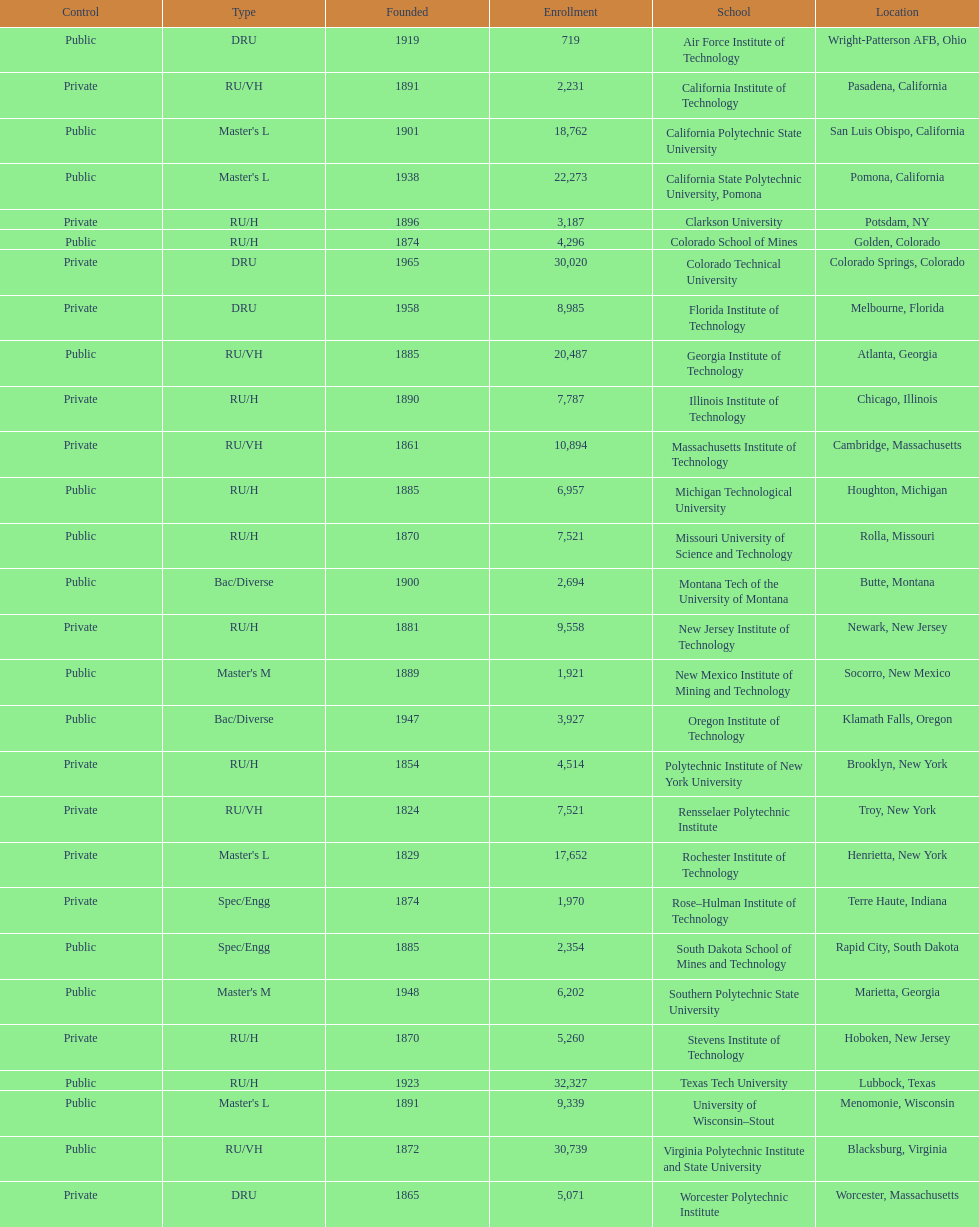Which us technological university has the top enrollment numbers? Texas Tech University. 